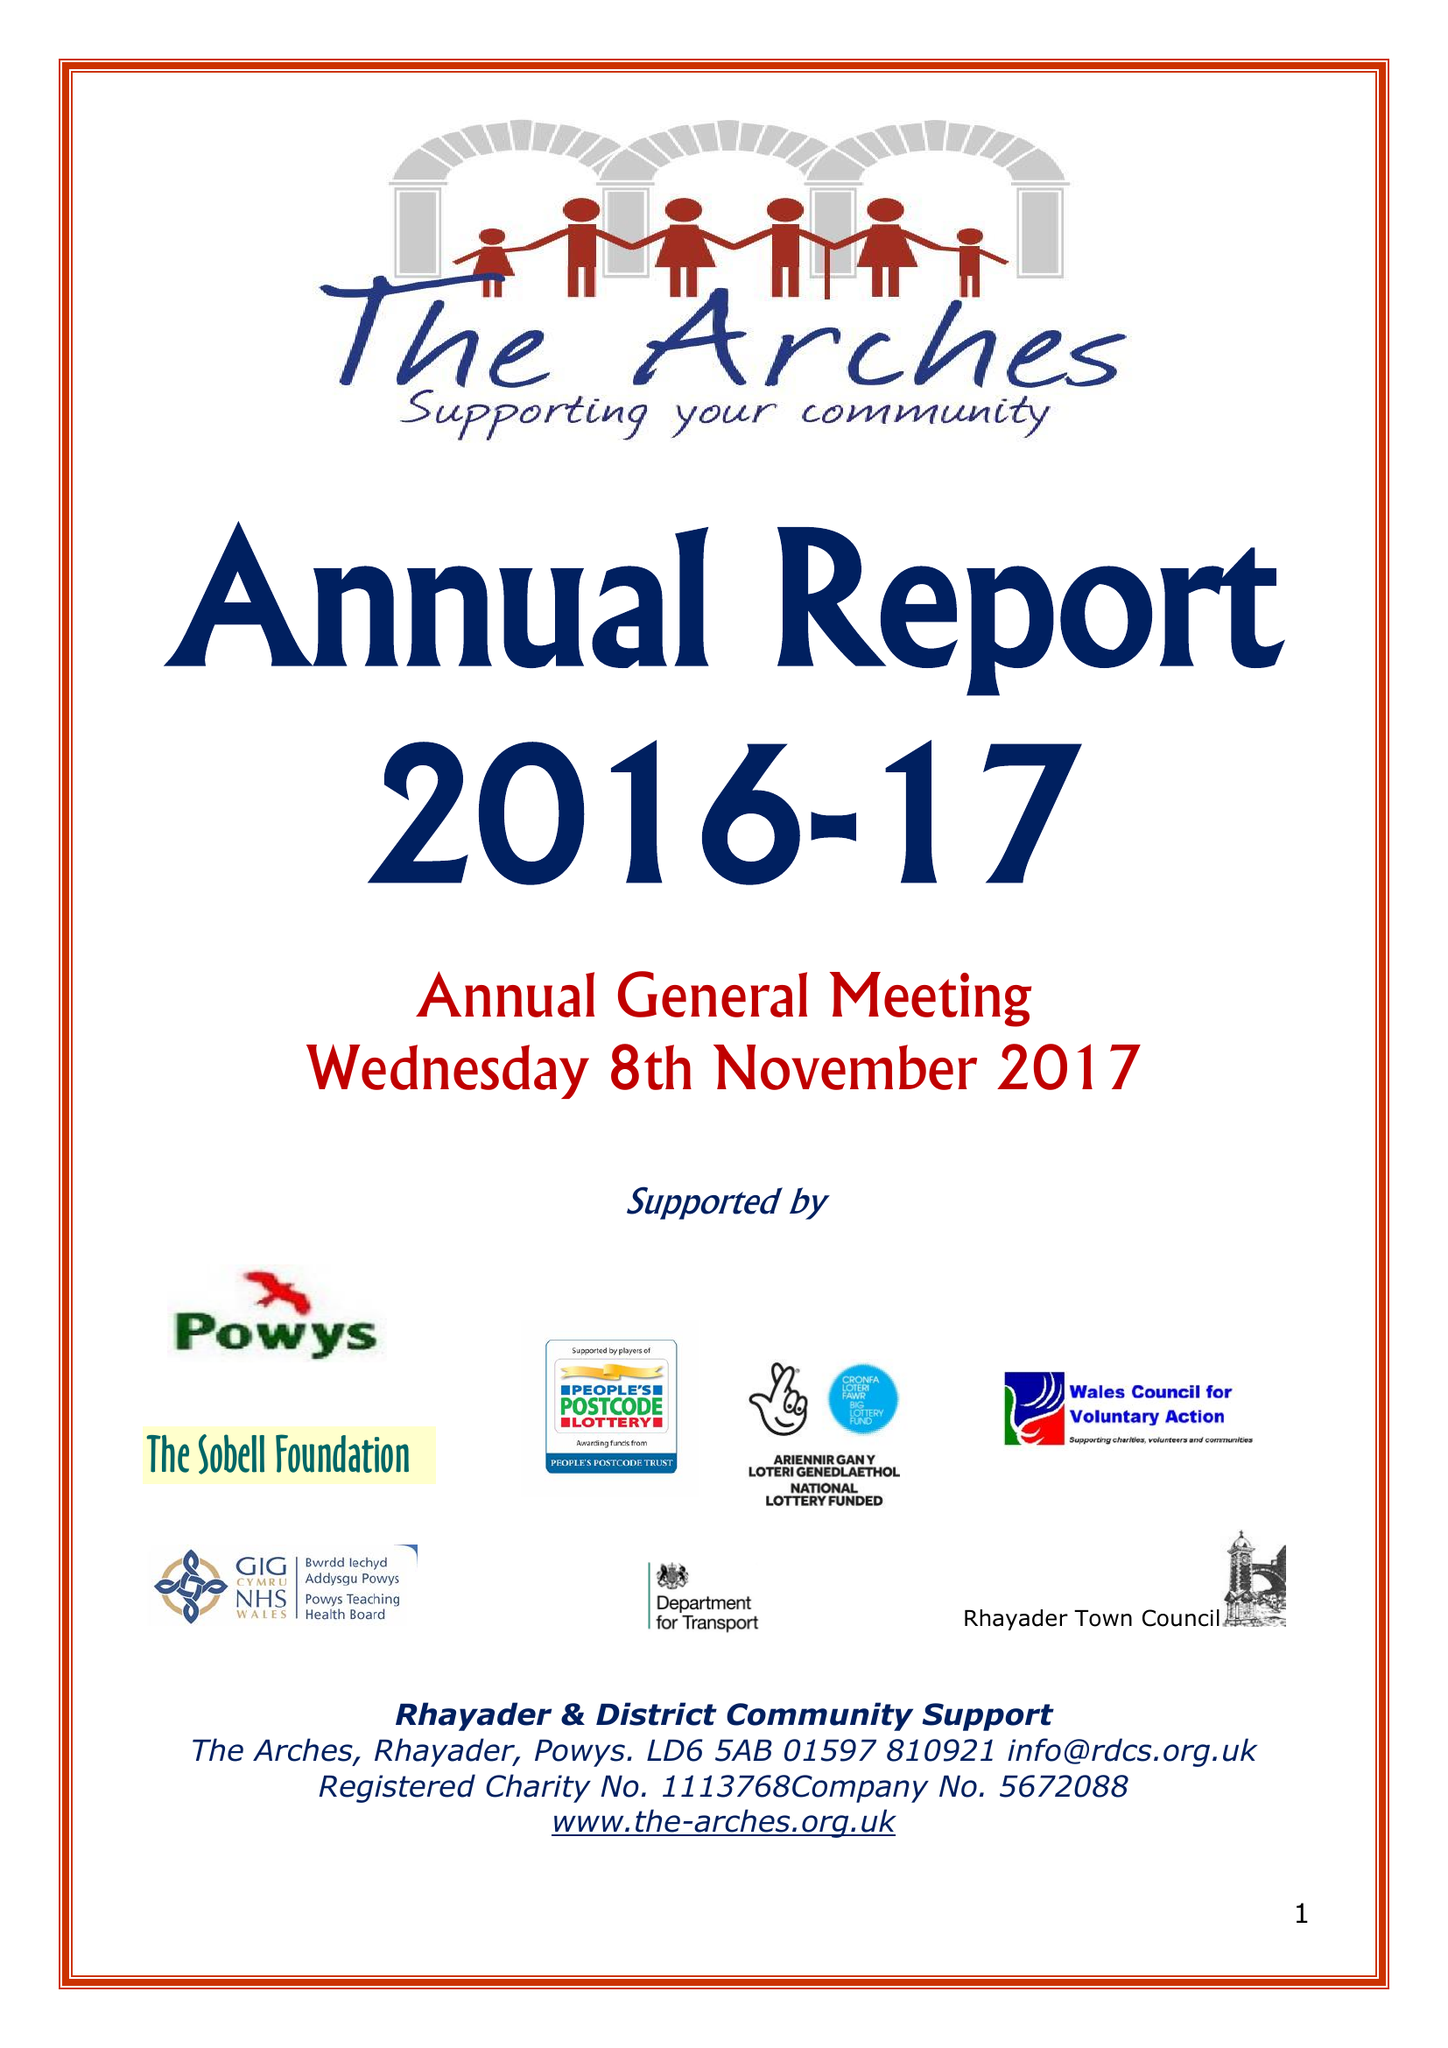What is the value for the spending_annually_in_british_pounds?
Answer the question using a single word or phrase. 242190.00 